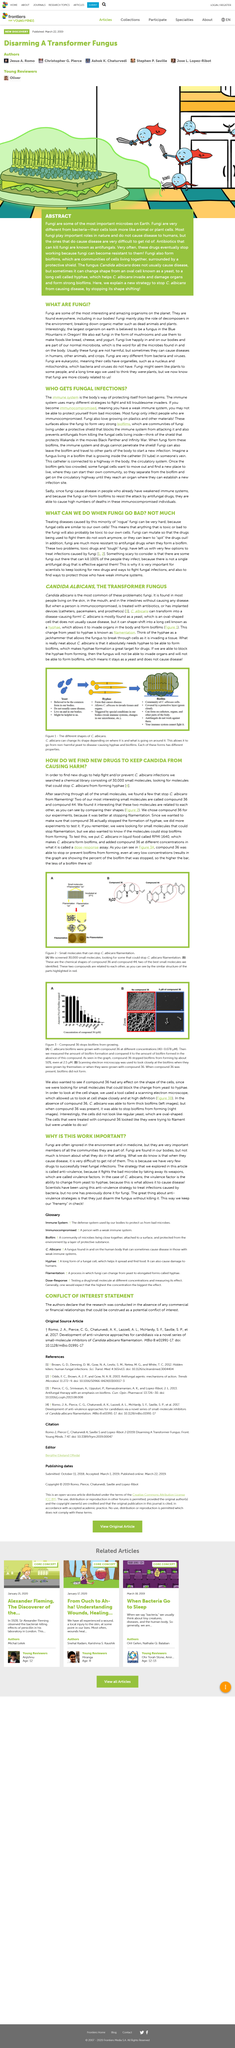Identify some key points in this picture. Regular yeast cells are typically oval in shape. The immune system is a crucial component of the body's defense mechanisms that functions to protect it from the harmful effects of bad genes. Compound 36 was chosen for the experiment to stop filamentation. In Figure B, scanning electron microscopy was utilized to examine the biofilms in detail. In Figure B, the images on the right show the results of a study where compound 36 was present. The results showed that when compound 36 was present, it was able to stop biofilms from forming. 